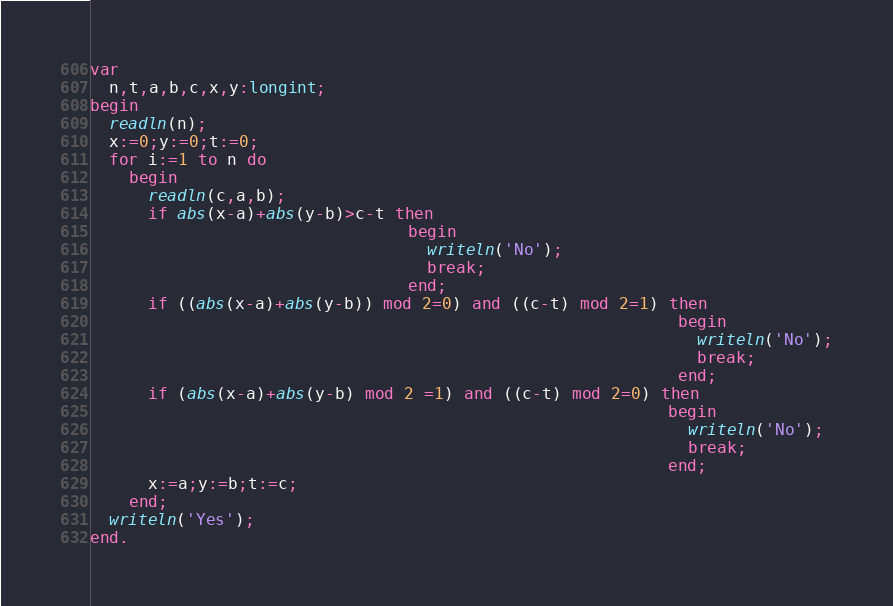<code> <loc_0><loc_0><loc_500><loc_500><_Pascal_>var
  n,t,a,b,c,x,y:longint;
begin
  readln(n);
  x:=0;y:=0;t:=0;
  for i:=1 to n do
    begin
      readln(c,a,b);
      if abs(x-a)+abs(y-b)>c-t then
                                 begin
                                   writeln('No');
                                   break;
                                 end;
      if ((abs(x-a)+abs(y-b)) mod 2=0) and ((c-t) mod 2=1) then
                                                             begin
                                                               writeln('No');
                                                               break;
                                                             end;
      if (abs(x-a)+abs(y-b) mod 2 =1) and ((c-t) mod 2=0) then
                                                            begin
                                                              writeln('No');
                                                              break;
                                                            end;
      x:=a;y:=b;t:=c;
    end;
  writeln('Yes');
end.</code> 